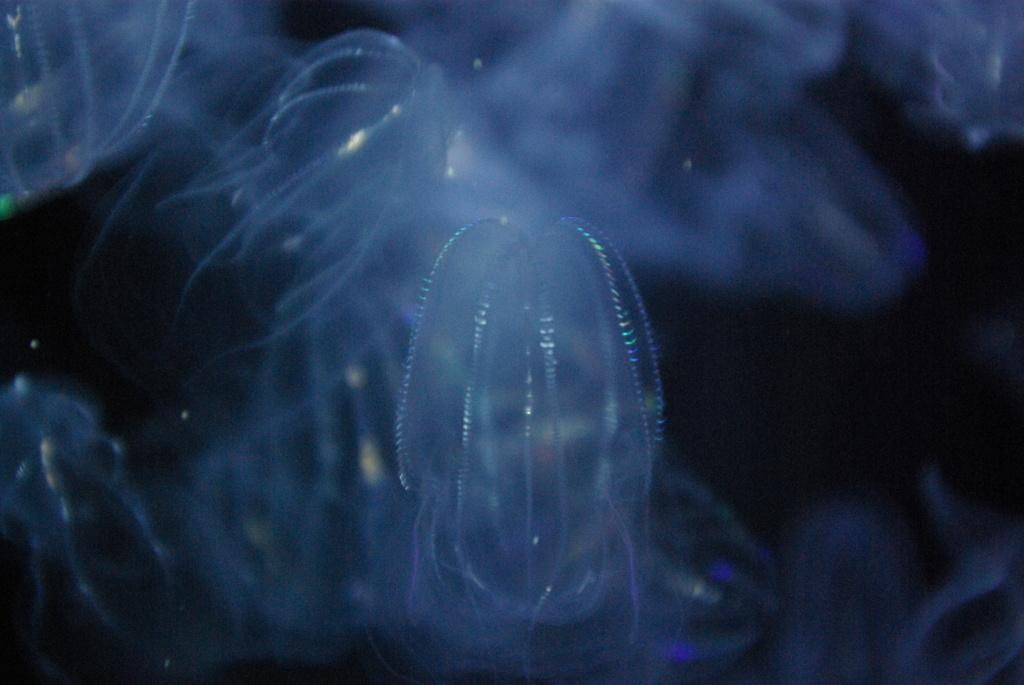What type of sea creatures are in the image? There are jellyfish in the image. What can be observed about the background of the image? The background of the image is dark. How many chickens are present in the image? There are no chickens present in the image; it features jellyfish. What type of reward can be seen being given to the jellyfish in the image? There is no reward being given to the jellyfish in the image; it is a still image of jellyfish in a dark background. 